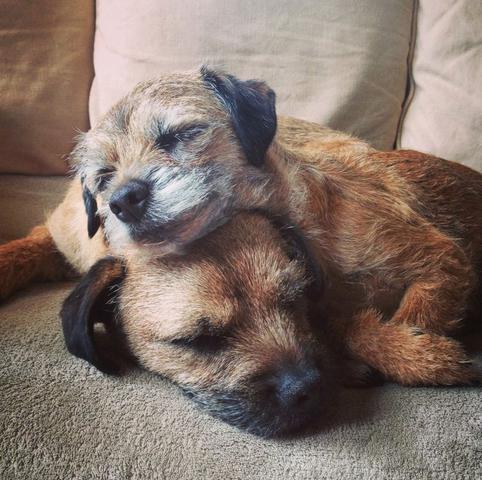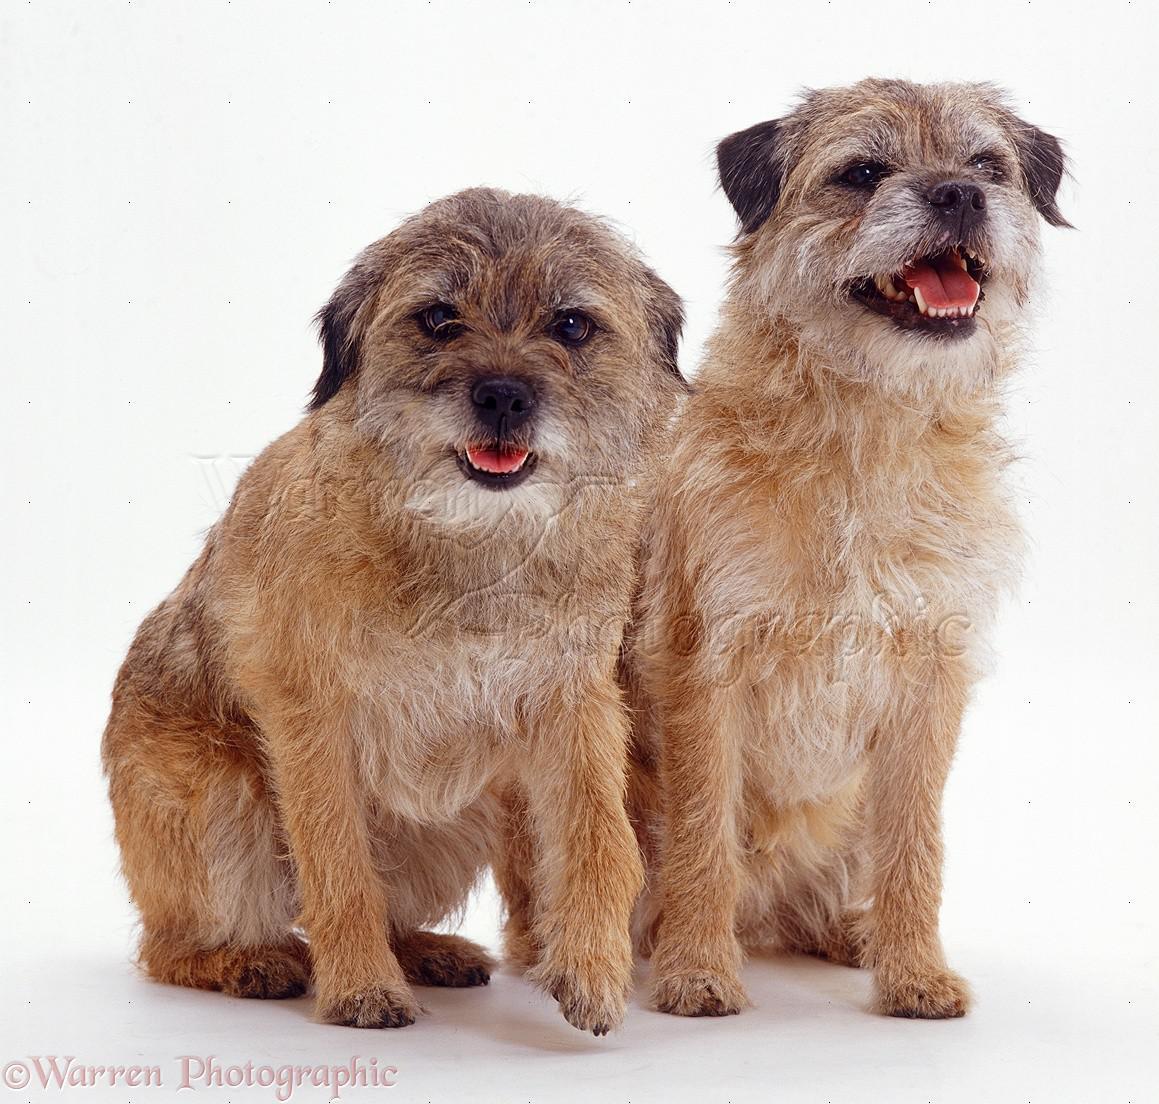The first image is the image on the left, the second image is the image on the right. For the images displayed, is the sentence "An image shows two dogs resting together with something pillow-like." factually correct? Answer yes or no. Yes. 